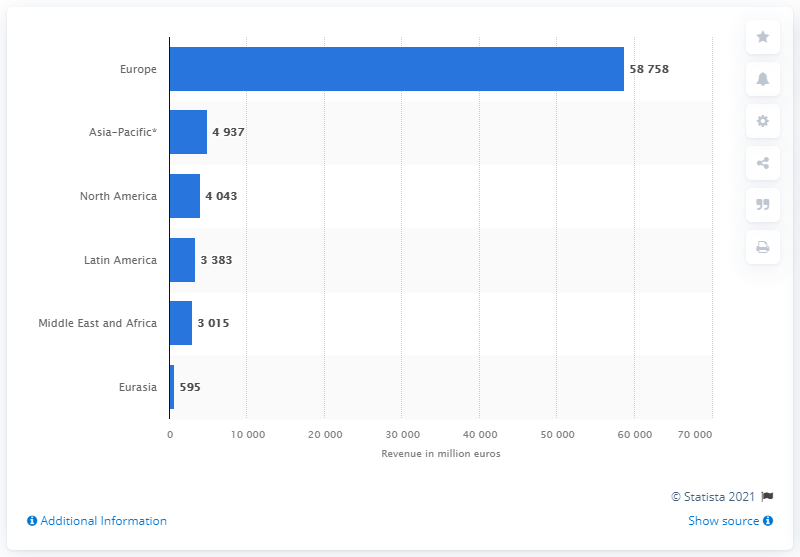Give some essential details in this illustration. In 2019, PSA Peugeot Citroen generated a total of €587,588 in revenue from its operations in Europe. The largest market for PSA Peugeot Citroen is Europe. 